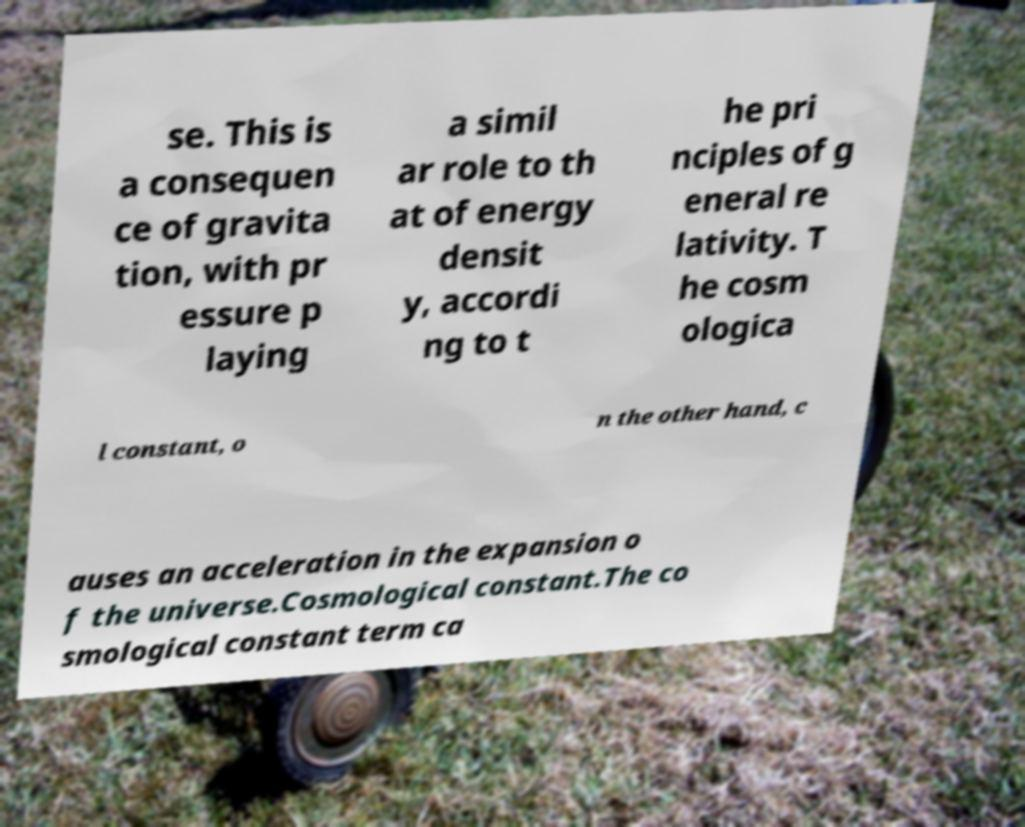Can you accurately transcribe the text from the provided image for me? se. This is a consequen ce of gravita tion, with pr essure p laying a simil ar role to th at of energy densit y, accordi ng to t he pri nciples of g eneral re lativity. T he cosm ologica l constant, o n the other hand, c auses an acceleration in the expansion o f the universe.Cosmological constant.The co smological constant term ca 